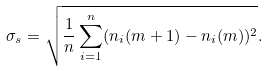<formula> <loc_0><loc_0><loc_500><loc_500>\sigma _ { s } = \sqrt { \frac { 1 } { n } \sum _ { i = 1 } ^ { n } ( n _ { i } ( m + 1 ) - n _ { i } ( m ) ) ^ { 2 } } .</formula> 